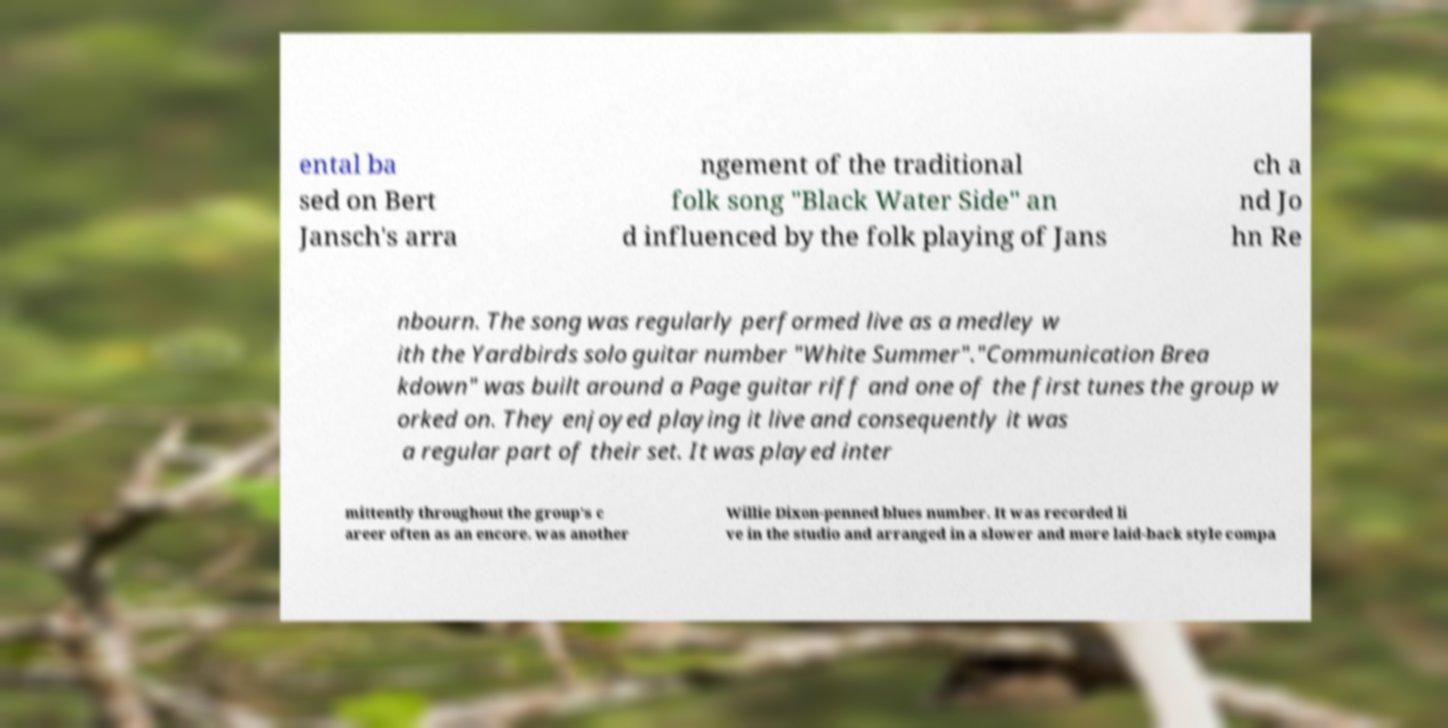I need the written content from this picture converted into text. Can you do that? ental ba sed on Bert Jansch's arra ngement of the traditional folk song "Black Water Side" an d influenced by the folk playing of Jans ch a nd Jo hn Re nbourn. The song was regularly performed live as a medley w ith the Yardbirds solo guitar number "White Summer"."Communication Brea kdown" was built around a Page guitar riff and one of the first tunes the group w orked on. They enjoyed playing it live and consequently it was a regular part of their set. It was played inter mittently throughout the group's c areer often as an encore. was another Willie Dixon-penned blues number. It was recorded li ve in the studio and arranged in a slower and more laid-back style compa 